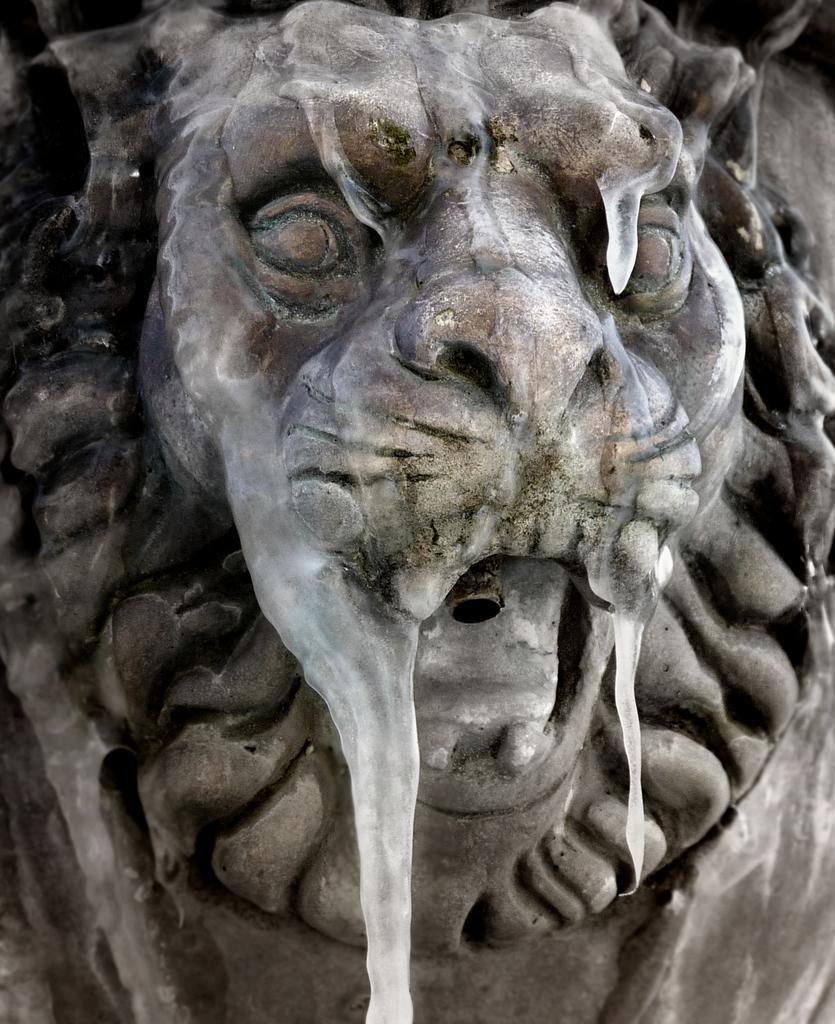How would you summarize this image in a sentence or two? In this image there is a statue of a lion in the middle. 